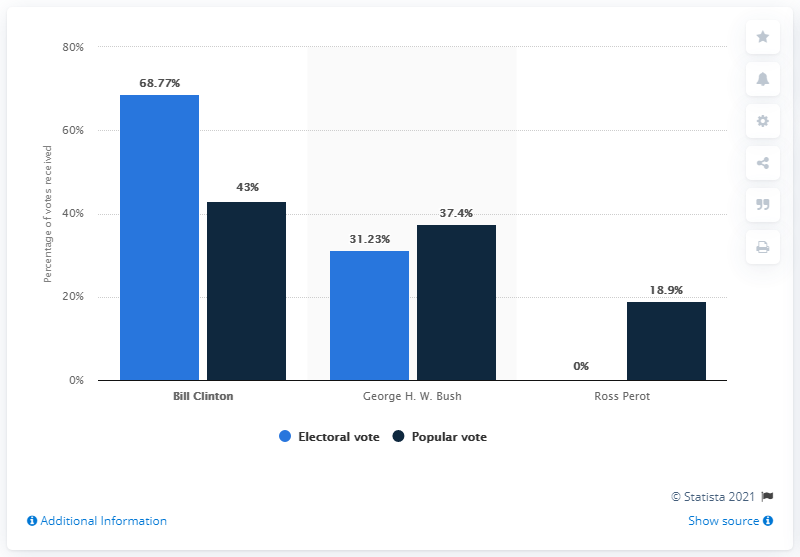Draw attention to some important aspects in this diagram. In the 1992 US presidential election, Ross Perot was the independent candidate. In the 1992 presidential election, Ross Perot received both electoral and popular votes. Specifically, he received 18.9% of the popular vote and 19% of the electoral vote. In the 1992 presidential election, Bill Clinton received the most electoral votes among all candidates. The winner of the 1992 U.S. presidential election was George H.W. Bush. 